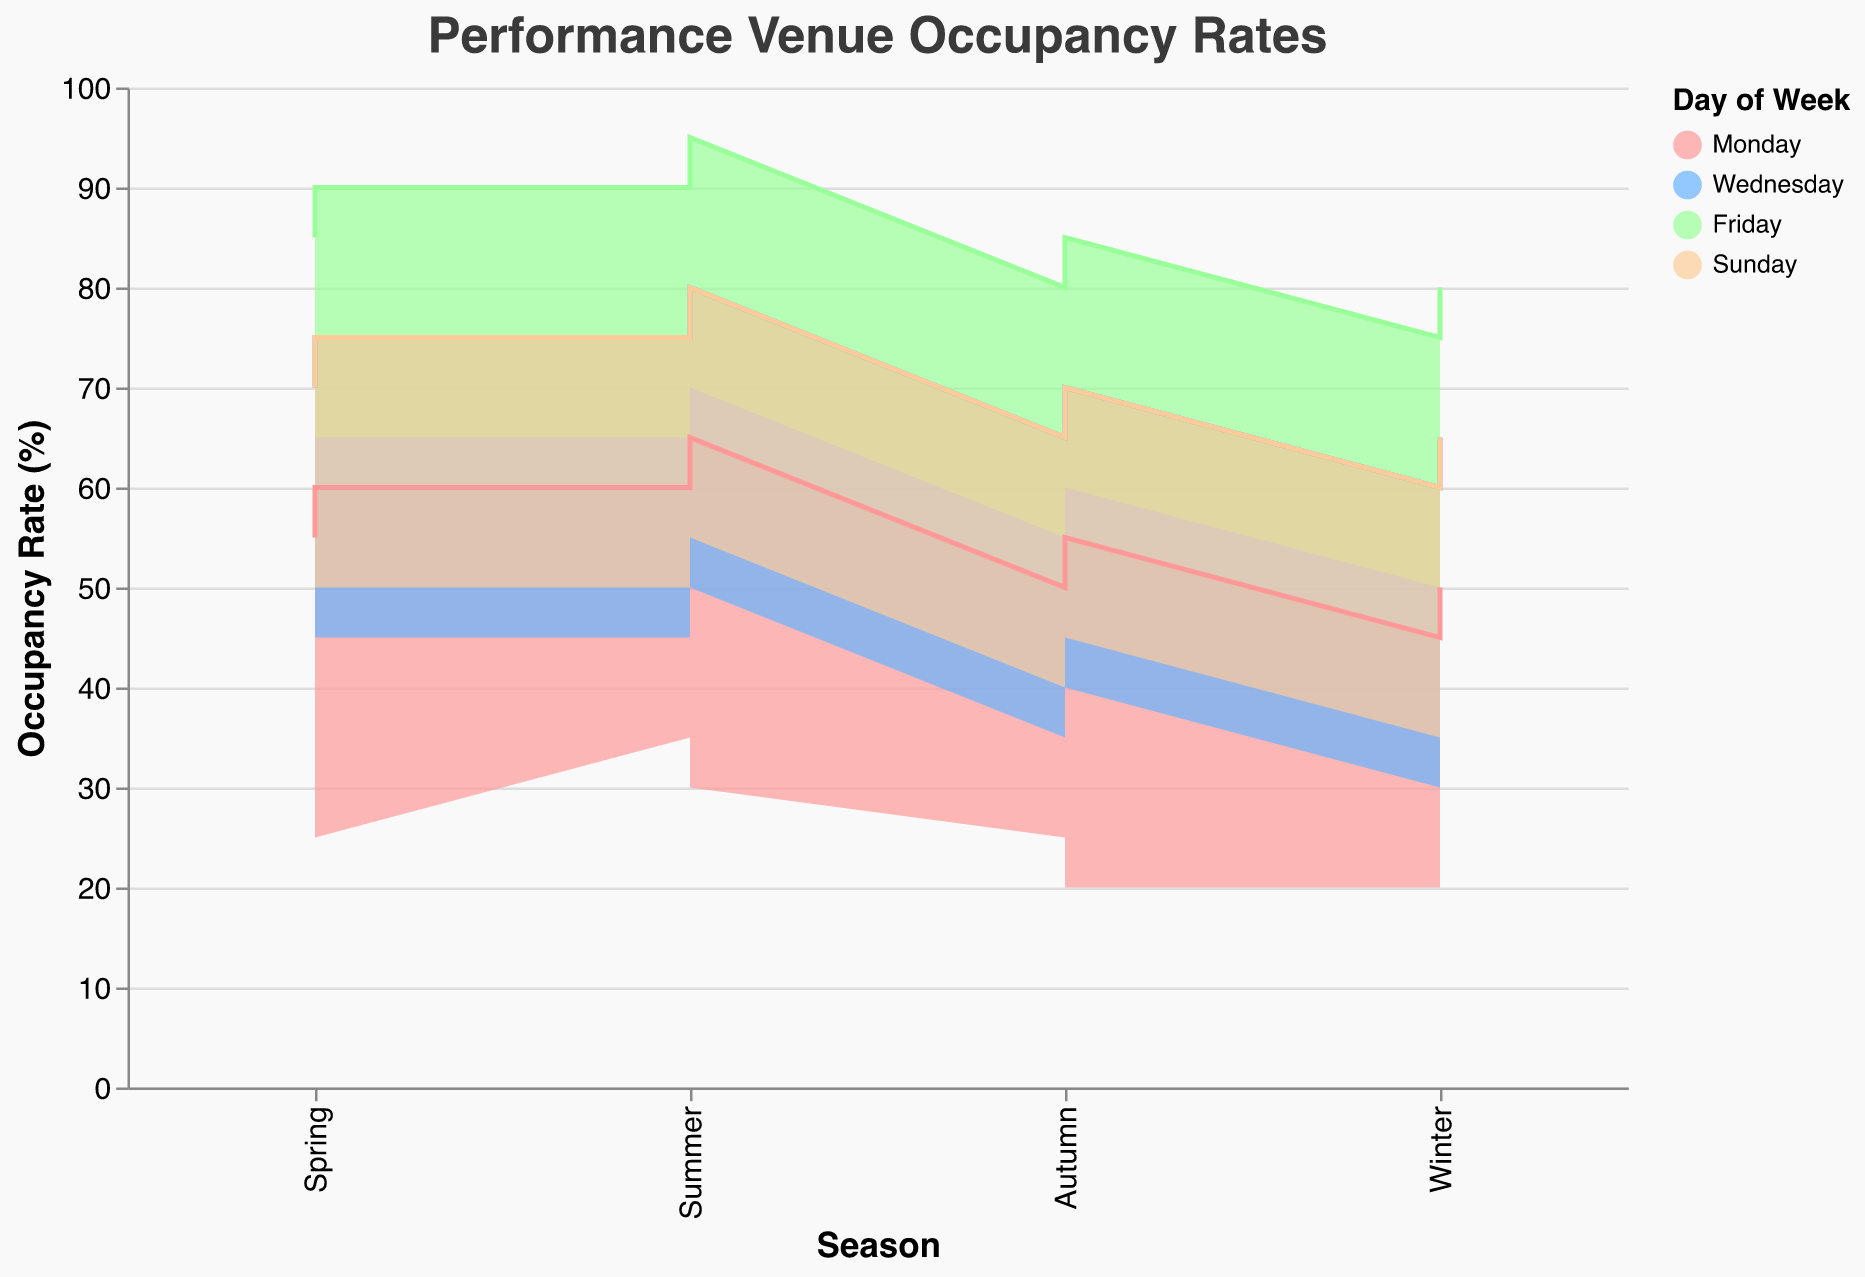What is the title of the chart? The title is displayed prominently at the top of the chart.
Answer: Performance Venue Occupancy Rates Which day of the week has the highest maximum occupancy rate in summer? Look at the highest points in the 'Summer' columns for all days: 95% for Friday at Webster Hall.
Answer: Friday What is the minimum occupancy rate at Mercury Lounge on a Monday in the autumn? Find the minimum occupancy rate for Mercury Lounge on Monday, Autumn: 20%.
Answer: 20% How does the minimum occupancy rate on Winter Sundays compare between The Bitter End and Bowery Ballroom? Compare the Winter Sunday minimum rates for both venues: 35% for The Bitter End, 40% for Bowery Ballroom.
Answer: Bowery Ballroom has a higher rate What is the average maximum occupancy rate for Wednesday in the winter? Sum the winter maximum rates for Wednesday (60% + 65%) and divide by 2.
Answer: 62.5% Which venue has the smallest range of occupancy rates in Spring for Sundays? Calculate the range (Max - Min) for each venue on Spring Sundays: 
The Bitter End (70% - 45%) = 25%, Bowery Ballroom (75% - 50%) = 25%. Both are equal.
Answer: The Bitter End and Bowery Ballroom Which day of the week shows the largest variation in occupancy rates throughout the year at The Blue Note venue? Calculate the range for each season on Monday at The Blue Note: 
Spring (55% - 30%) = 25%, 
Summer (60% - 35%) = 25%, 
Autumn (50% - 25%) = 25%, 
Winter (45% - 20%) = 25%. All are equal.
Answer: Monday What is the difference in maximum occupancy rates between Friday and Monday in Summer at the House of Blues? Compare Summer maximums for House of Blues (90%) and Monday (Mercury Lounge, The Blue Note): 90% − 65% = 25%.
Answer: 25% How does the maximum occupancy rate for Wednesday at Whiskey a Go Go in summer compare to The Troubadour? Summer maximum for Whiskey a Go Go: 75%, The Troubadour: 80%. Troubadour is higher.
Answer: The Troubadour is higher On average, do occupancy rates tend to be higher in summer or winter across all venues? Calculate the overall average for Summer and Winter maximum rates. Summer rates tend higher compared to Winter rates.
Answer: Summer 